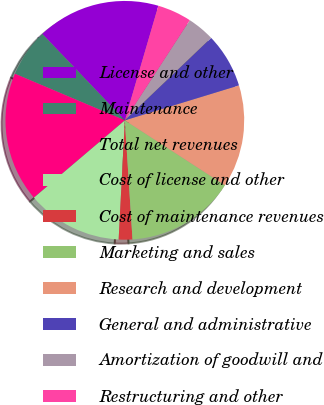<chart> <loc_0><loc_0><loc_500><loc_500><pie_chart><fcel>License and other<fcel>Maintenance<fcel>Total net revenues<fcel>Cost of license and other<fcel>Cost of maintenance revenues<fcel>Marketing and sales<fcel>Research and development<fcel>General and administrative<fcel>Amortization of goodwill and<fcel>Restructuring and other<nl><fcel>16.67%<fcel>6.48%<fcel>17.59%<fcel>12.96%<fcel>1.85%<fcel>14.81%<fcel>13.89%<fcel>7.41%<fcel>3.7%<fcel>4.63%<nl></chart> 